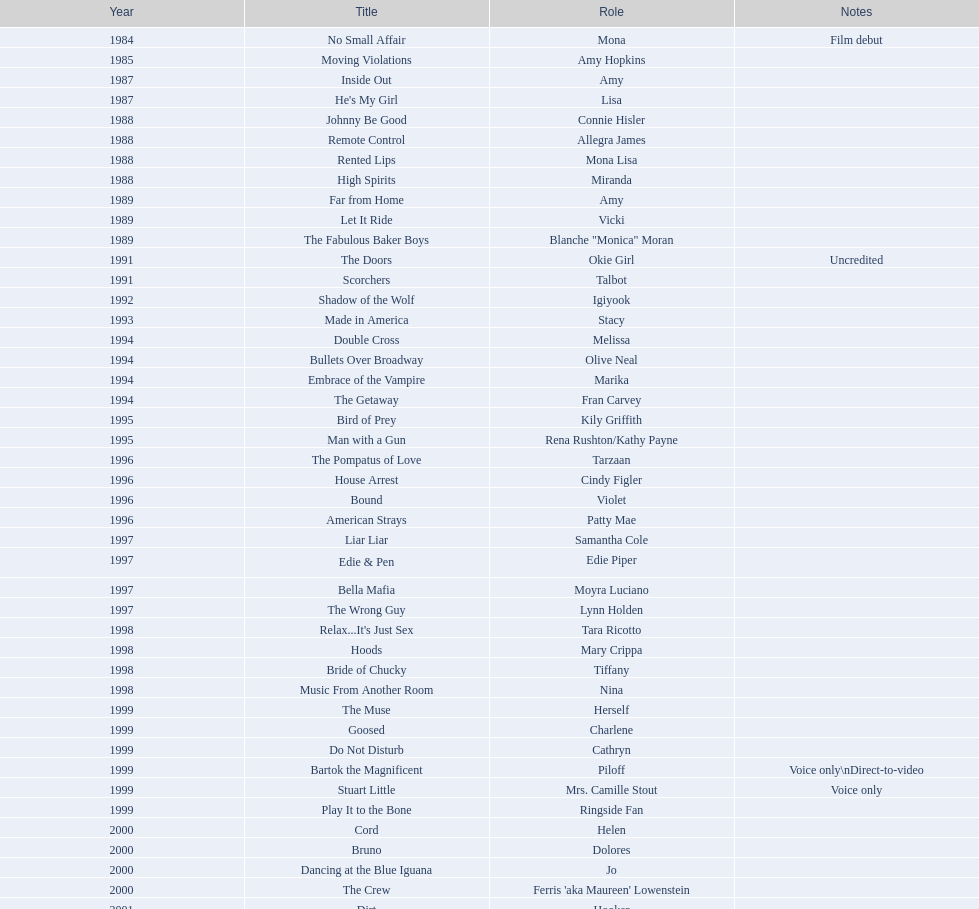Which film aired in 1994 and has marika as the role? Embrace of the Vampire. Parse the full table. {'header': ['Year', 'Title', 'Role', 'Notes'], 'rows': [['1984', 'No Small Affair', 'Mona', 'Film debut'], ['1985', 'Moving Violations', 'Amy Hopkins', ''], ['1987', 'Inside Out', 'Amy', ''], ['1987', "He's My Girl", 'Lisa', ''], ['1988', 'Johnny Be Good', 'Connie Hisler', ''], ['1988', 'Remote Control', 'Allegra James', ''], ['1988', 'Rented Lips', 'Mona Lisa', ''], ['1988', 'High Spirits', 'Miranda', ''], ['1989', 'Far from Home', 'Amy', ''], ['1989', 'Let It Ride', 'Vicki', ''], ['1989', 'The Fabulous Baker Boys', 'Blanche "Monica" Moran', ''], ['1991', 'The Doors', 'Okie Girl', 'Uncredited'], ['1991', 'Scorchers', 'Talbot', ''], ['1992', 'Shadow of the Wolf', 'Igiyook', ''], ['1993', 'Made in America', 'Stacy', ''], ['1994', 'Double Cross', 'Melissa', ''], ['1994', 'Bullets Over Broadway', 'Olive Neal', ''], ['1994', 'Embrace of the Vampire', 'Marika', ''], ['1994', 'The Getaway', 'Fran Carvey', ''], ['1995', 'Bird of Prey', 'Kily Griffith', ''], ['1995', 'Man with a Gun', 'Rena Rushton/Kathy Payne', ''], ['1996', 'The Pompatus of Love', 'Tarzaan', ''], ['1996', 'House Arrest', 'Cindy Figler', ''], ['1996', 'Bound', 'Violet', ''], ['1996', 'American Strays', 'Patty Mae', ''], ['1997', 'Liar Liar', 'Samantha Cole', ''], ['1997', 'Edie & Pen', 'Edie Piper', ''], ['1997', 'Bella Mafia', 'Moyra Luciano', ''], ['1997', 'The Wrong Guy', 'Lynn Holden', ''], ['1998', "Relax...It's Just Sex", 'Tara Ricotto', ''], ['1998', 'Hoods', 'Mary Crippa', ''], ['1998', 'Bride of Chucky', 'Tiffany', ''], ['1998', 'Music From Another Room', 'Nina', ''], ['1999', 'The Muse', 'Herself', ''], ['1999', 'Goosed', 'Charlene', ''], ['1999', 'Do Not Disturb', 'Cathryn', ''], ['1999', 'Bartok the Magnificent', 'Piloff', 'Voice only\\nDirect-to-video'], ['1999', 'Stuart Little', 'Mrs. Camille Stout', 'Voice only'], ['1999', 'Play It to the Bone', 'Ringside Fan', ''], ['2000', 'Cord', 'Helen', ''], ['2000', 'Bruno', 'Dolores', ''], ['2000', 'Dancing at the Blue Iguana', 'Jo', ''], ['2000', 'The Crew', "Ferris 'aka Maureen' Lowenstein", ''], ['2001', 'Dirt', 'Hooker', ''], ['2001', 'Fast Sofa', 'Ginger Quail', ''], ['2001', 'Monsters, Inc.', 'Celia Mae', 'Voice only'], ['2001', 'Ball in the House', 'Dot', ''], ['2001', "The Cat's Meow", 'Louella Parsons', ''], ['2003', 'Hollywood North', 'Gillian Stevens', ''], ['2003', 'The Haunted Mansion', 'Madame Leota', ''], ['2003', 'Happy End', 'Edna', ''], ['2003', 'Jericho Mansions', 'Donna Cherry', ''], ['2004', 'Second Best', 'Carole', ''], ['2004', 'Perfect Opposites', 'Elyse Steinberg', ''], ['2004', 'Home on the Range', 'Grace', 'Voice only'], ['2004', 'El Padrino', 'Sebeva', ''], ['2004', 'Saint Ralph', 'Nurse Alice', ''], ['2004', 'Love on the Side', 'Alma Kerns', ''], ['2004', 'Seed of Chucky', 'Tiffany/Herself', ''], ['2005', "Bailey's Billion$", 'Dolores Pennington', ''], ['2005', "Lil' Pimp", 'Miss De La Croix', 'Voice only'], ['2005', 'The Civilization of Maxwell Bright', "Dr. O'Shannon", ''], ['2005', 'Tideland', 'Queen Gunhilda', ''], ['2006', 'The Poker Movie', 'Herself', ''], ['2007', 'Intervention', '', ''], ['2008', 'Deal', "Karen 'Razor' Jones", ''], ['2008', 'The Caretaker', 'Miss Perry', ''], ['2008', 'Bart Got a Room', 'Melinda', ''], ['2008', 'Inconceivable', "Salome 'Sally' Marsh", ''], ['2009', 'An American Girl: Chrissa Stands Strong', 'Mrs. Rundell', ''], ['2009', 'Imps', '', ''], ['2009', 'Made in Romania', 'Herself', ''], ['2009', 'Empire of Silver', 'Mrs. Landdeck', ''], ['2010', 'The Making of Plus One', 'Amber', ''], ['2010', 'The Secret Lives of Dorks', 'Ms. Stewart', ''], ['2012', '30 Beats', 'Erika', ''], ['2013', 'Curse of Chucky', 'Tiffany Ray', 'Cameo, Direct-to-video']]} 